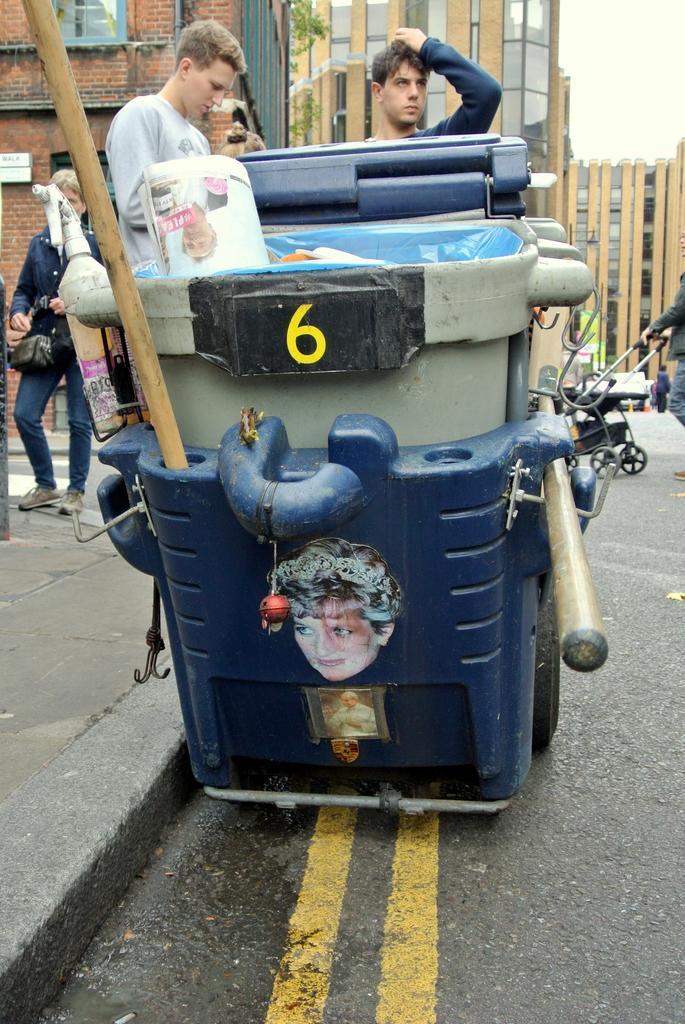In one or two sentences, can you explain what this image depicts? In this picture there are some vehicles and persons, two people were standing on the vehicle, there is a person holding the vehicle on the road, in the background there are some buildings. 